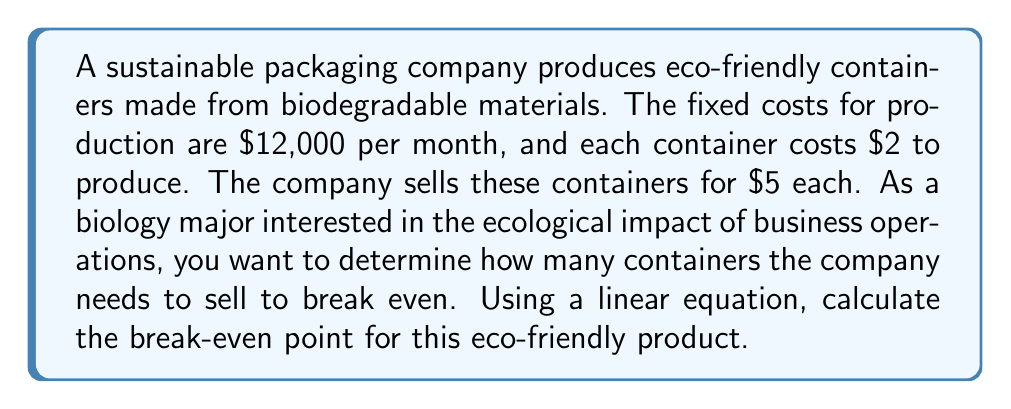Help me with this question. To solve this problem, we'll use the break-even formula derived from a linear equation:

1. Let's define our variables:
   $x$ = number of containers sold
   $R$ = Revenue
   $C$ = Total Costs
   $P$ = Profit

2. We can express Revenue as: $R = 5x$ (price per container × number of containers)

3. Total Costs can be expressed as: $C = 12000 + 2x$ (fixed costs + variable costs per container × number of containers)

4. At the break-even point, Profit is zero, so:
   $P = R - C = 0$

5. We can now set up our break-even equation:
   $R = C$
   $5x = 12000 + 2x$

6. Solve for $x$:
   $5x - 2x = 12000$
   $3x = 12000$
   $x = 4000$

Therefore, the company needs to sell 4,000 containers to break even.

To verify:
Revenue: $5 × 4000 = $20,000
Costs: $12000 + (2 × 4000) = $20,000

This solution demonstrates how linear equations can be used to analyze the economic viability of eco-friendly products, which is crucial for understanding the balance between environmental sustainability and business operations.
Answer: The break-even point is 4,000 containers. 